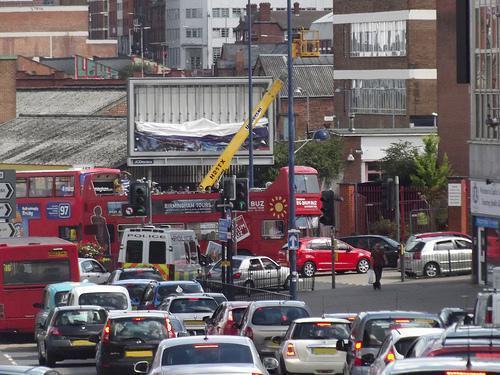How many police vehicles?
Give a very brief answer. 1. How many yellow cars are there?
Give a very brief answer. 0. 